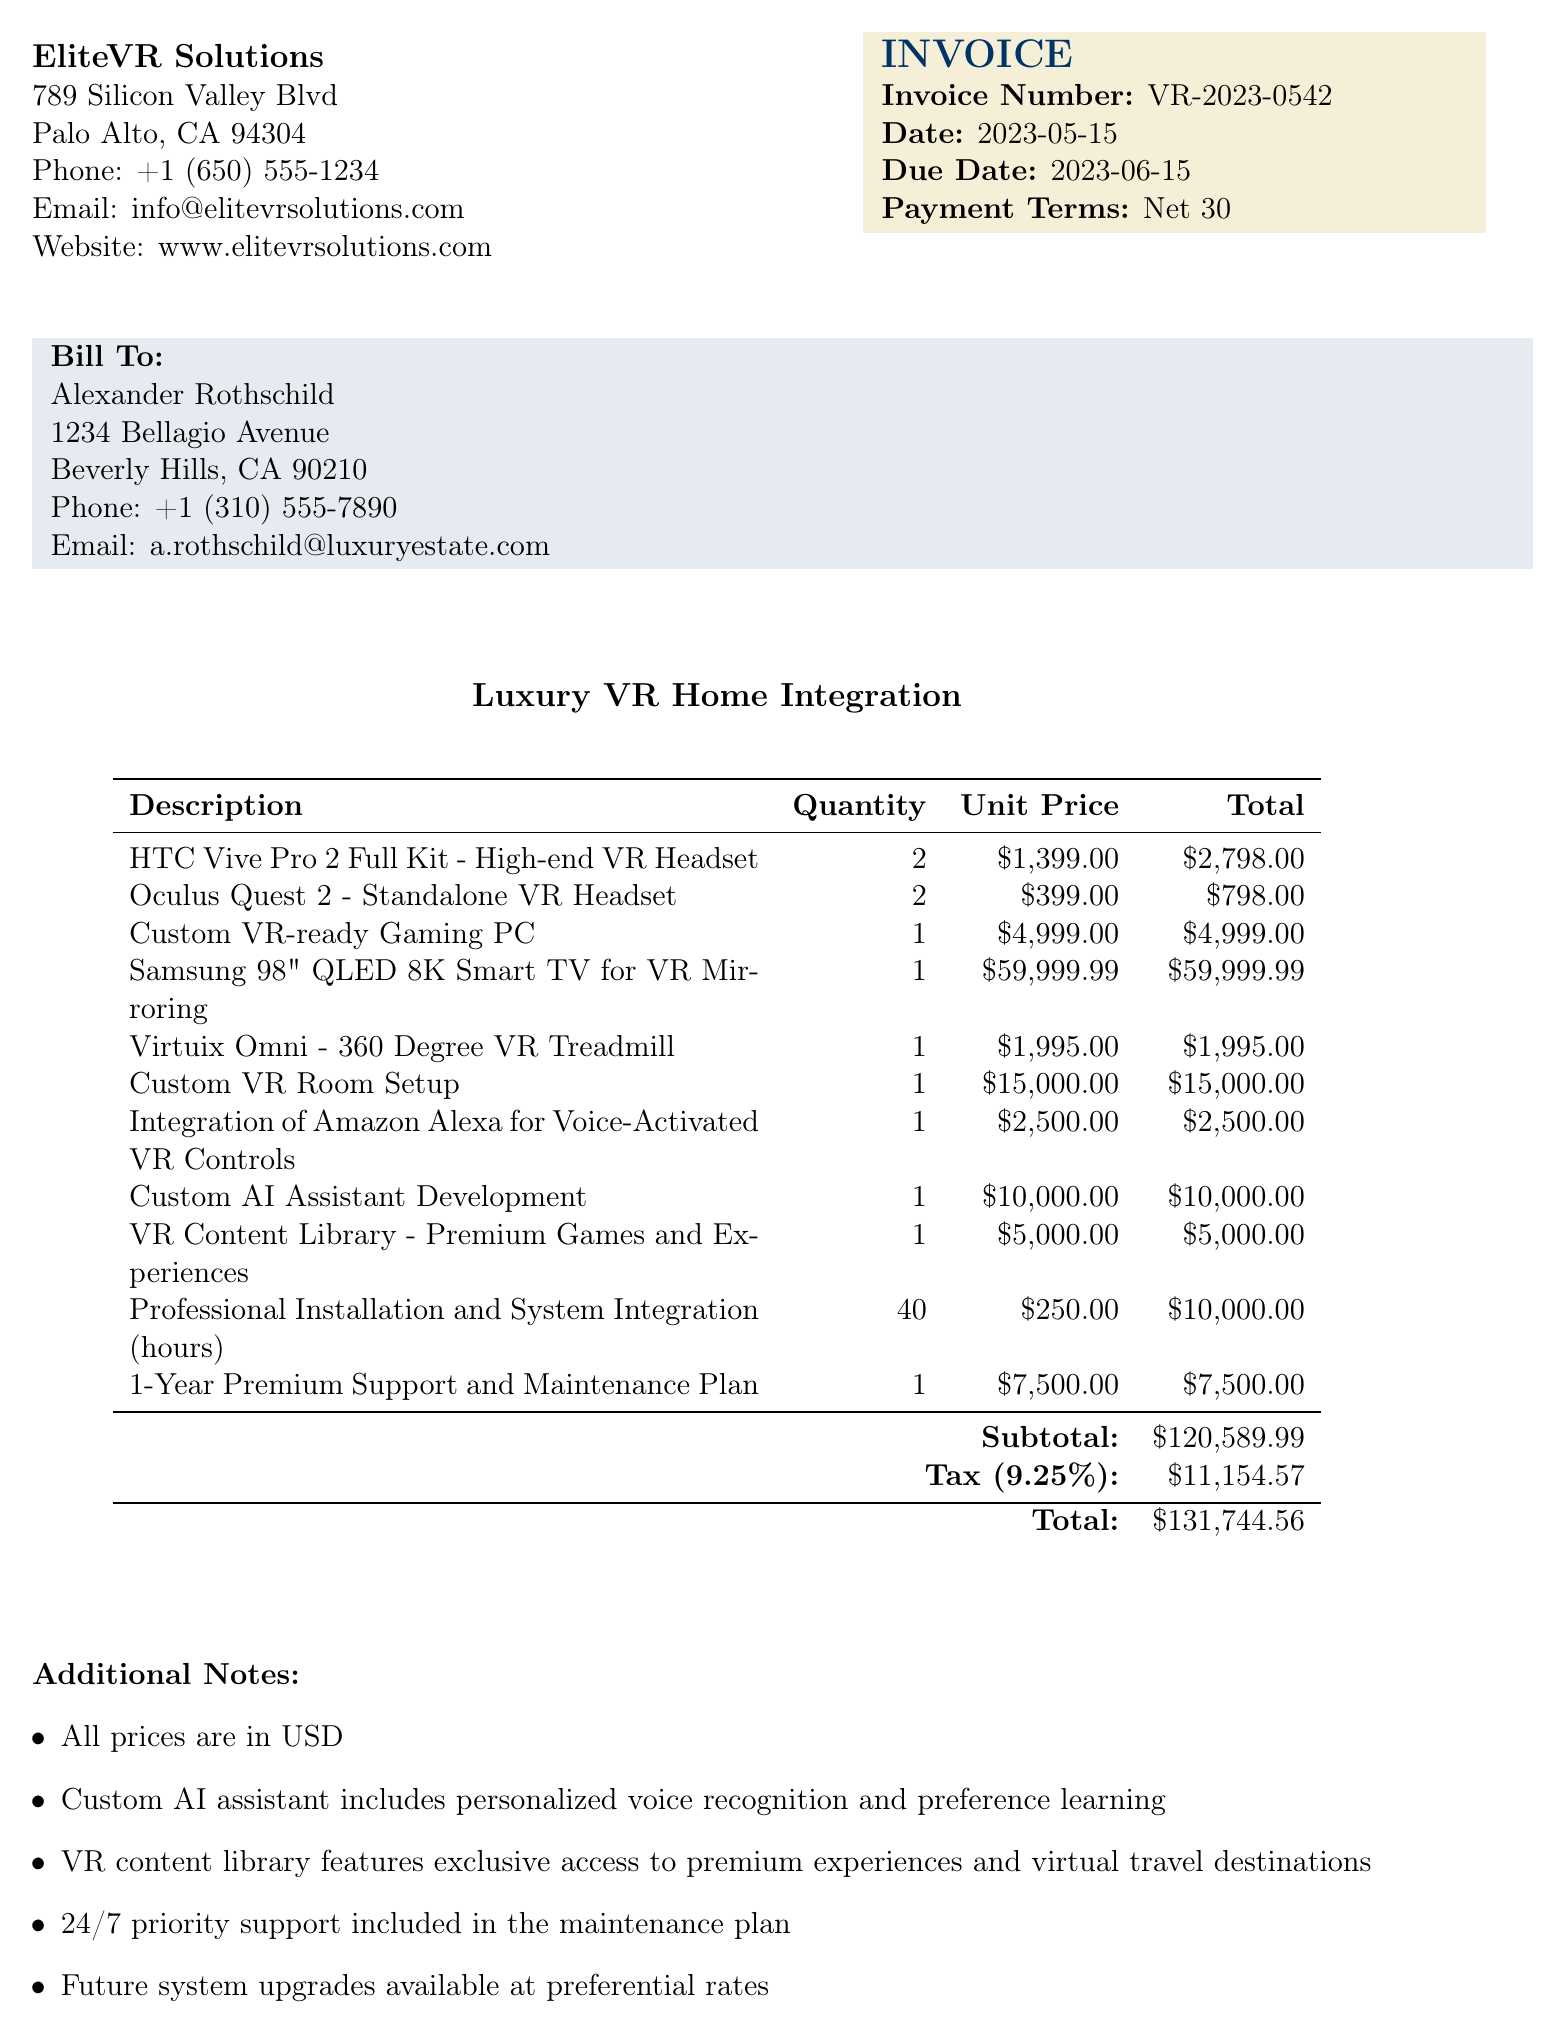What is the invoice number? The invoice number can be found under the invoice details section, which states the number assigned to this particular invoice.
Answer: VR-2023-0542 What is the total amount due? The total amount due is the final amount after adding the subtotal and tax, indicated at the bottom of the invoice table.
Answer: 131744.56 How many HTC Vive Pro 2 headsets were purchased? The quantity of HTC Vive Pro 2 headsets is listed in the line items of the invoice.
Answer: 2 What is the tax rate applied to this invoice? The tax rate is provided as a percentage at the bottom of the invoice table, indicating the tax amount calculated on the subtotal.
Answer: 9.25% What is included in the 1-Year Premium Support and Maintenance Plan? The description for support and maintenance is stated in the additional notes section, highlighting what it entails for the client.
Answer: 24/7 priority support How many professional installation hours were billed? The quantity of hours for professional installation is detailed in the line items section of the invoice.
Answer: 40 What is the unit price for the Samsung 98-inch QLED 8K Smart TV? The unit price for the Samsung TV can be found in the line items section, specifically next to the item description.
Answer: 59999.99 Who is the client for this invoice? The client name is listed under the billing information section, indicating the person responsible for payment.
Answer: Alexander Rothschild What company issued the invoice? The company name is provided at the top of the invoice, indicating the provider of the services detailed within.
Answer: EliteVR Solutions 